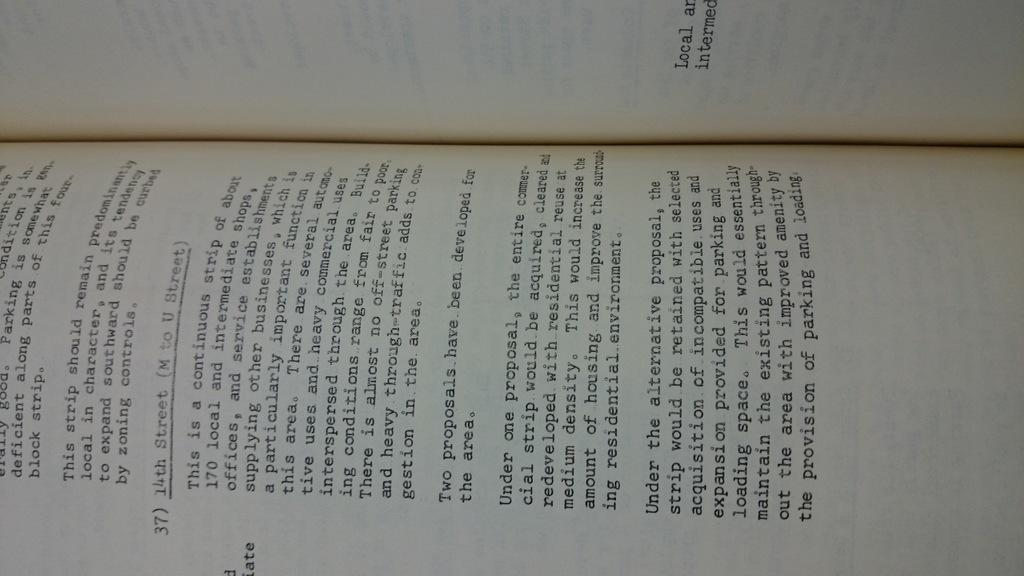Provide a one-sentence caption for the provided image. An open book curved in a way common to open books with text. 